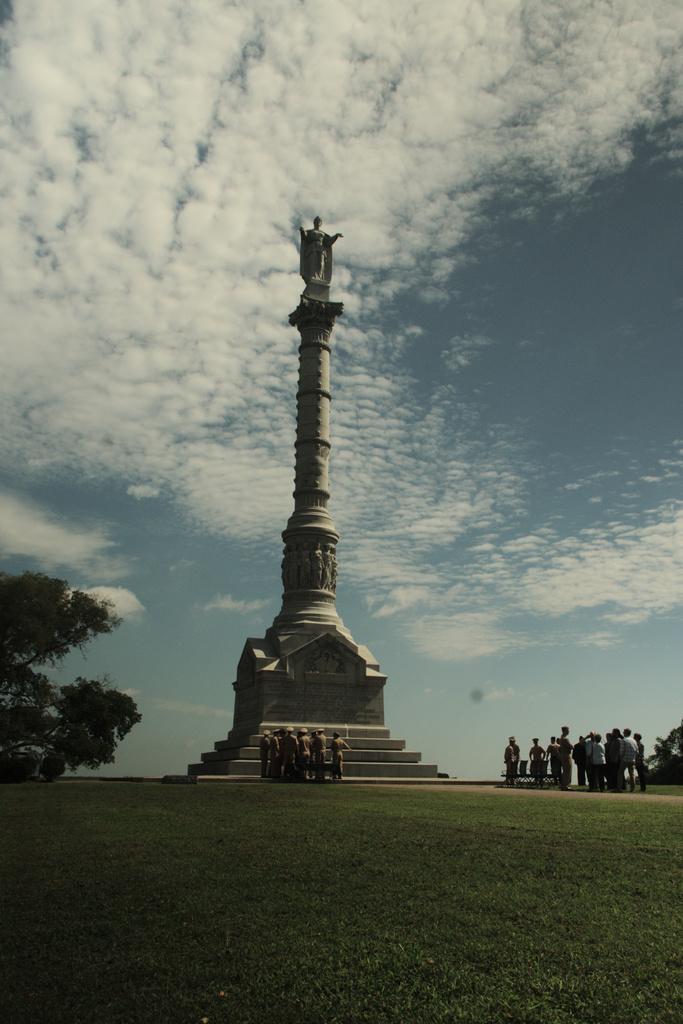Please provide a concise description of this image. In this image I can see few stairs, a building and on it I can see huge pole on which I can see a statue of a person. I can see number of persons are standing on the ground, few trees and in the background I can see the sky. 